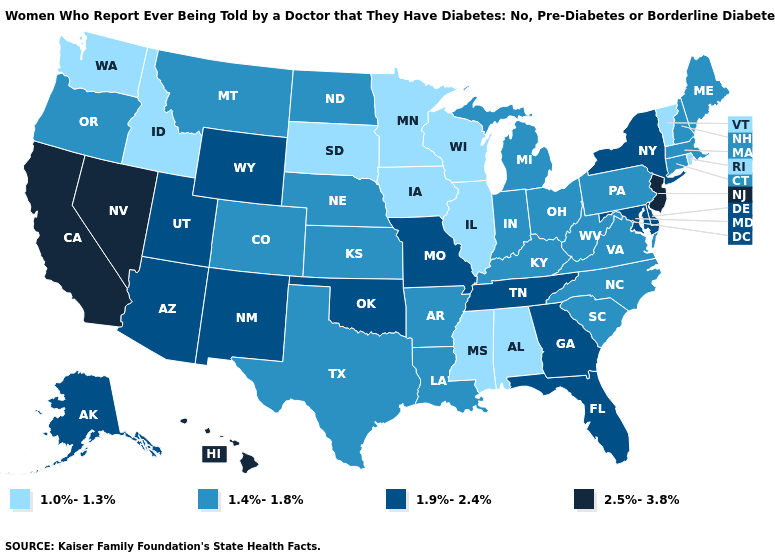Name the states that have a value in the range 1.4%-1.8%?
Give a very brief answer. Arkansas, Colorado, Connecticut, Indiana, Kansas, Kentucky, Louisiana, Maine, Massachusetts, Michigan, Montana, Nebraska, New Hampshire, North Carolina, North Dakota, Ohio, Oregon, Pennsylvania, South Carolina, Texas, Virginia, West Virginia. What is the highest value in the USA?
Be succinct. 2.5%-3.8%. Name the states that have a value in the range 1.9%-2.4%?
Quick response, please. Alaska, Arizona, Delaware, Florida, Georgia, Maryland, Missouri, New Mexico, New York, Oklahoma, Tennessee, Utah, Wyoming. What is the highest value in the Northeast ?
Keep it brief. 2.5%-3.8%. Does South Carolina have the same value as Wyoming?
Short answer required. No. What is the value of Idaho?
Quick response, please. 1.0%-1.3%. Which states have the lowest value in the USA?
Answer briefly. Alabama, Idaho, Illinois, Iowa, Minnesota, Mississippi, Rhode Island, South Dakota, Vermont, Washington, Wisconsin. Does Michigan have the lowest value in the MidWest?
Give a very brief answer. No. Does Nevada have the highest value in the USA?
Be succinct. Yes. What is the lowest value in the USA?
Give a very brief answer. 1.0%-1.3%. What is the lowest value in the South?
Keep it brief. 1.0%-1.3%. Name the states that have a value in the range 2.5%-3.8%?
Write a very short answer. California, Hawaii, Nevada, New Jersey. Which states hav the highest value in the West?
Keep it brief. California, Hawaii, Nevada. What is the highest value in the Northeast ?
Answer briefly. 2.5%-3.8%. 